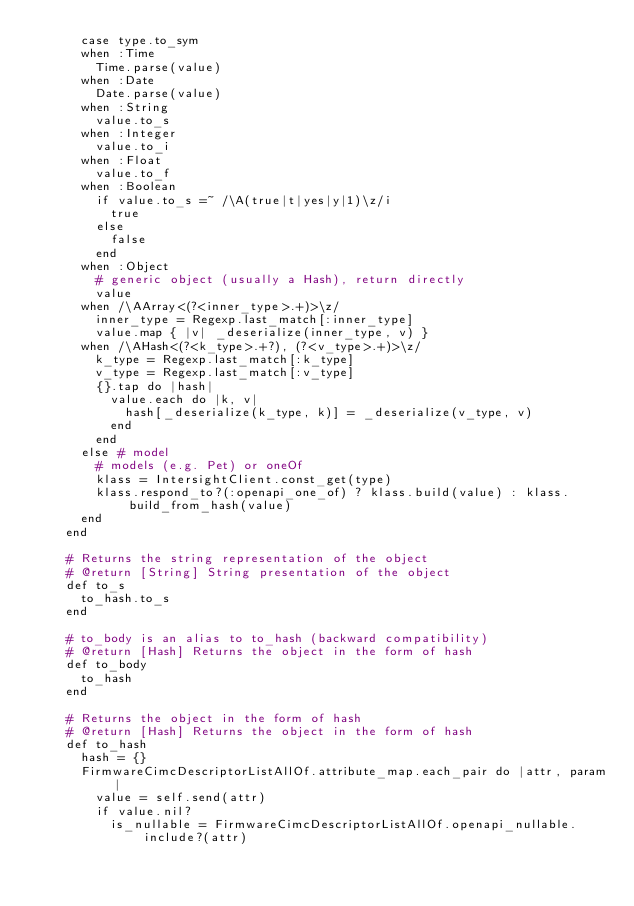<code> <loc_0><loc_0><loc_500><loc_500><_Ruby_>      case type.to_sym
      when :Time
        Time.parse(value)
      when :Date
        Date.parse(value)
      when :String
        value.to_s
      when :Integer
        value.to_i
      when :Float
        value.to_f
      when :Boolean
        if value.to_s =~ /\A(true|t|yes|y|1)\z/i
          true
        else
          false
        end
      when :Object
        # generic object (usually a Hash), return directly
        value
      when /\AArray<(?<inner_type>.+)>\z/
        inner_type = Regexp.last_match[:inner_type]
        value.map { |v| _deserialize(inner_type, v) }
      when /\AHash<(?<k_type>.+?), (?<v_type>.+)>\z/
        k_type = Regexp.last_match[:k_type]
        v_type = Regexp.last_match[:v_type]
        {}.tap do |hash|
          value.each do |k, v|
            hash[_deserialize(k_type, k)] = _deserialize(v_type, v)
          end
        end
      else # model
        # models (e.g. Pet) or oneOf
        klass = IntersightClient.const_get(type)
        klass.respond_to?(:openapi_one_of) ? klass.build(value) : klass.build_from_hash(value)
      end
    end

    # Returns the string representation of the object
    # @return [String] String presentation of the object
    def to_s
      to_hash.to_s
    end

    # to_body is an alias to to_hash (backward compatibility)
    # @return [Hash] Returns the object in the form of hash
    def to_body
      to_hash
    end

    # Returns the object in the form of hash
    # @return [Hash] Returns the object in the form of hash
    def to_hash
      hash = {}
      FirmwareCimcDescriptorListAllOf.attribute_map.each_pair do |attr, param|
        value = self.send(attr)
        if value.nil?
          is_nullable = FirmwareCimcDescriptorListAllOf.openapi_nullable.include?(attr)</code> 